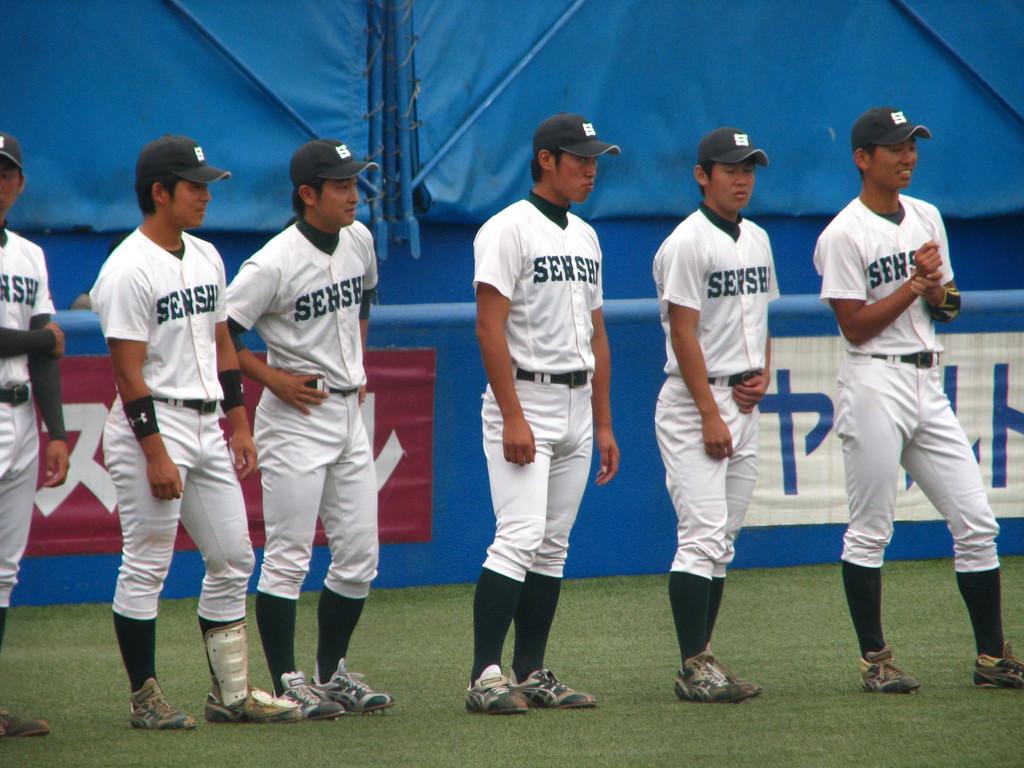What team is this?
Give a very brief answer. Senshi. 